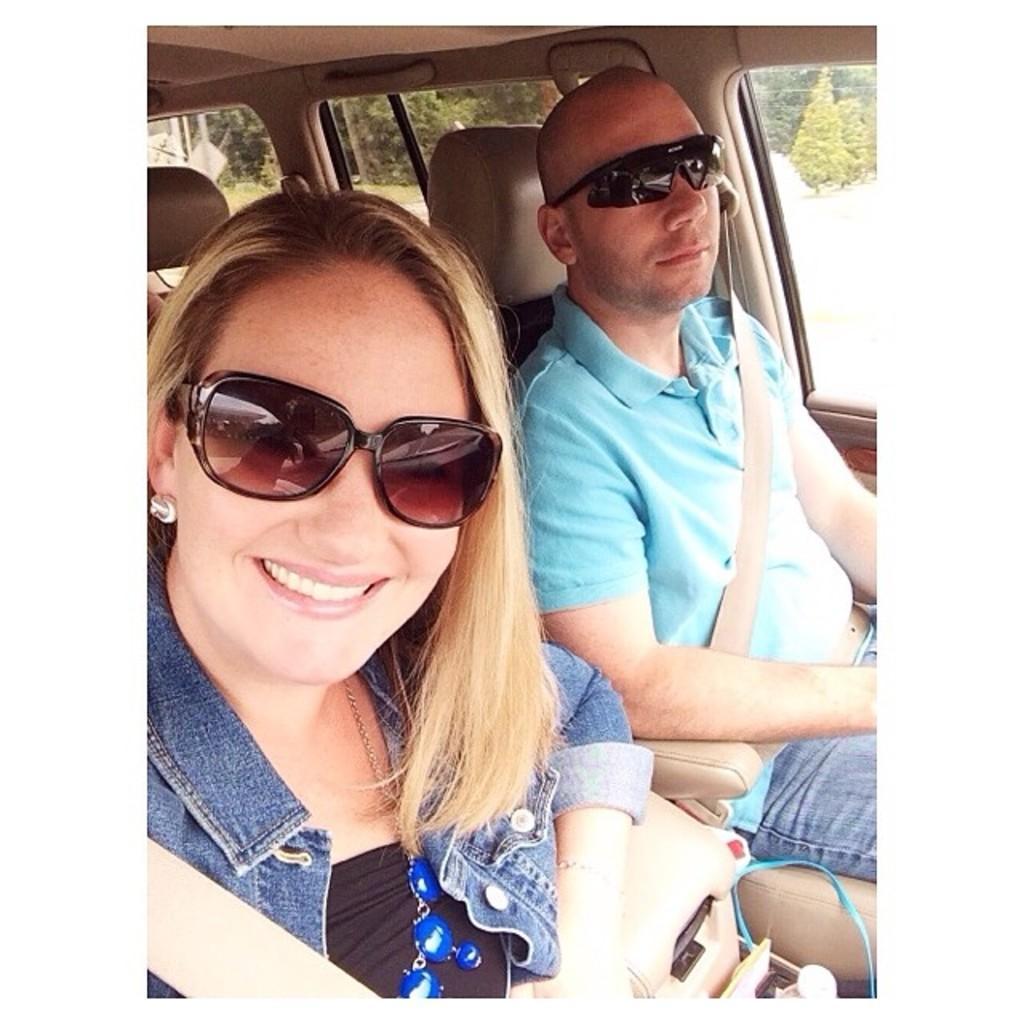How would you summarize this image in a sentence or two? This picture is taken inside a vehicle. A woman is sitting on the seat. She is wearing goggles. Beside her there is a person wearing goggles. From the windows of the vehicle few trees are visible. 